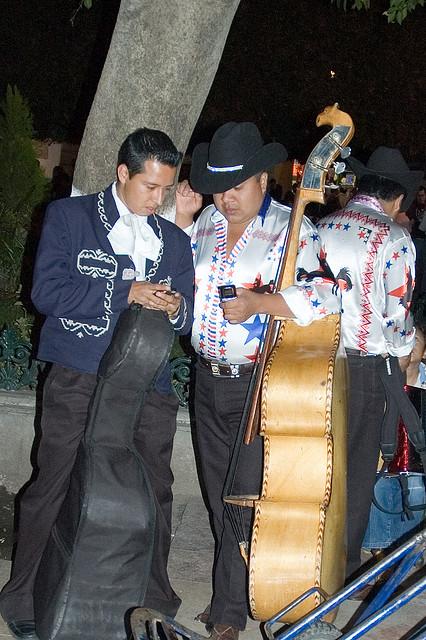What are the men holding?
Give a very brief answer. Instruments. What kind of music is he likely playing?
Concise answer only. Mariachi. How many cowboy hats?
Write a very short answer. 2. What instrument is the man using?
Keep it brief. Cello. 